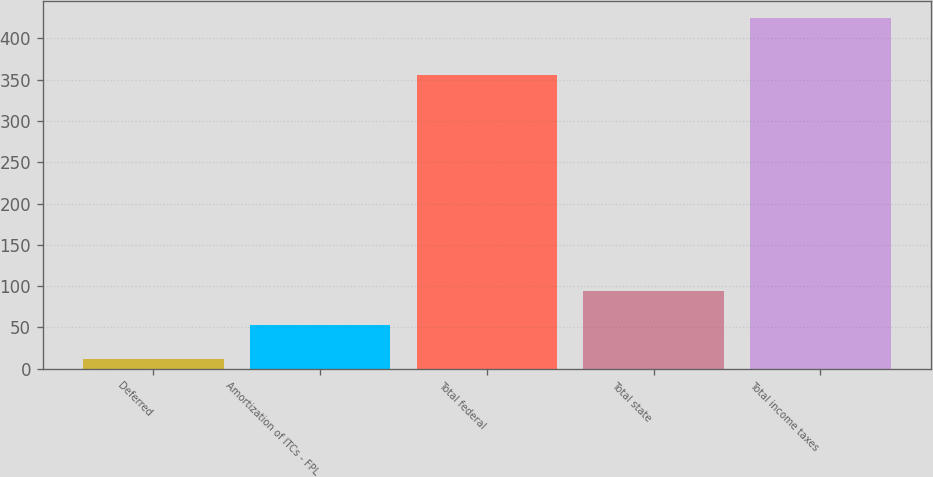Convert chart to OTSL. <chart><loc_0><loc_0><loc_500><loc_500><bar_chart><fcel>Deferred<fcel>Amortization of ITCs - FPL<fcel>Total federal<fcel>Total state<fcel>Total income taxes<nl><fcel>12<fcel>53.2<fcel>356<fcel>94.4<fcel>424<nl></chart> 